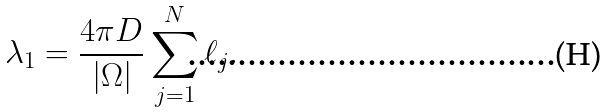<formula> <loc_0><loc_0><loc_500><loc_500>\lambda _ { 1 } = \frac { 4 \pi D } { | \Omega | } \sum _ { j = 1 } ^ { N } \ell _ { j } .</formula> 